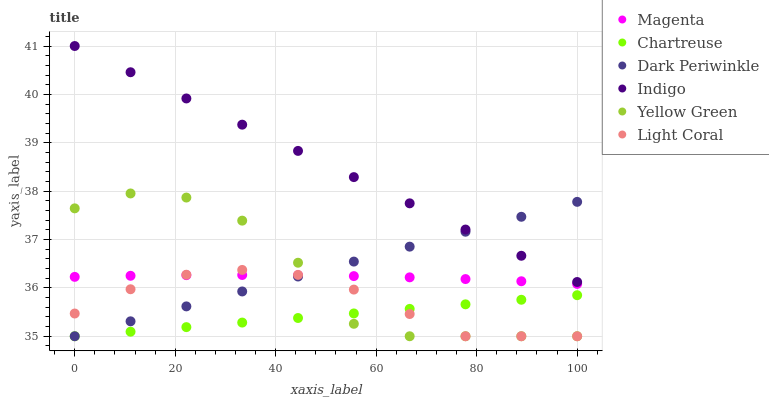Does Chartreuse have the minimum area under the curve?
Answer yes or no. Yes. Does Indigo have the maximum area under the curve?
Answer yes or no. Yes. Does Yellow Green have the minimum area under the curve?
Answer yes or no. No. Does Yellow Green have the maximum area under the curve?
Answer yes or no. No. Is Dark Periwinkle the smoothest?
Answer yes or no. Yes. Is Yellow Green the roughest?
Answer yes or no. Yes. Is Light Coral the smoothest?
Answer yes or no. No. Is Light Coral the roughest?
Answer yes or no. No. Does Yellow Green have the lowest value?
Answer yes or no. Yes. Does Magenta have the lowest value?
Answer yes or no. No. Does Indigo have the highest value?
Answer yes or no. Yes. Does Yellow Green have the highest value?
Answer yes or no. No. Is Chartreuse less than Magenta?
Answer yes or no. Yes. Is Indigo greater than Yellow Green?
Answer yes or no. Yes. Does Magenta intersect Yellow Green?
Answer yes or no. Yes. Is Magenta less than Yellow Green?
Answer yes or no. No. Is Magenta greater than Yellow Green?
Answer yes or no. No. Does Chartreuse intersect Magenta?
Answer yes or no. No. 